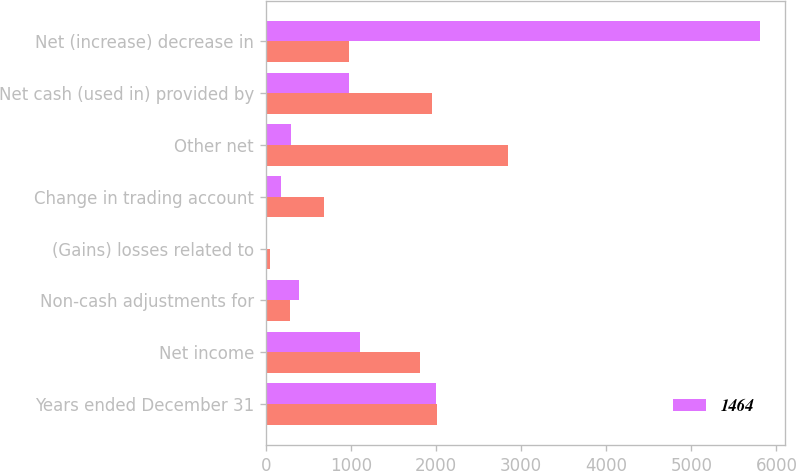Convert chart. <chart><loc_0><loc_0><loc_500><loc_500><stacked_bar_chart><ecel><fcel>Years ended December 31<fcel>Net income<fcel>Non-cash adjustments for<fcel>(Gains) losses related to<fcel>Change in trading account<fcel>Other net<fcel>Net cash (used in) provided by<fcel>Net (increase) decrease in<nl><fcel>nan<fcel>2008<fcel>1811<fcel>282<fcel>54<fcel>689<fcel>2850<fcel>1956<fcel>981<nl><fcel>1464<fcel>2006<fcel>1106<fcel>385<fcel>15<fcel>179<fcel>300<fcel>981<fcel>5809<nl></chart> 